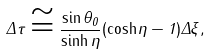<formula> <loc_0><loc_0><loc_500><loc_500>\Delta \tau \cong \frac { \sin \theta _ { 0 } } { \sinh \eta } ( \cosh \eta - 1 ) \Delta \xi ,</formula> 